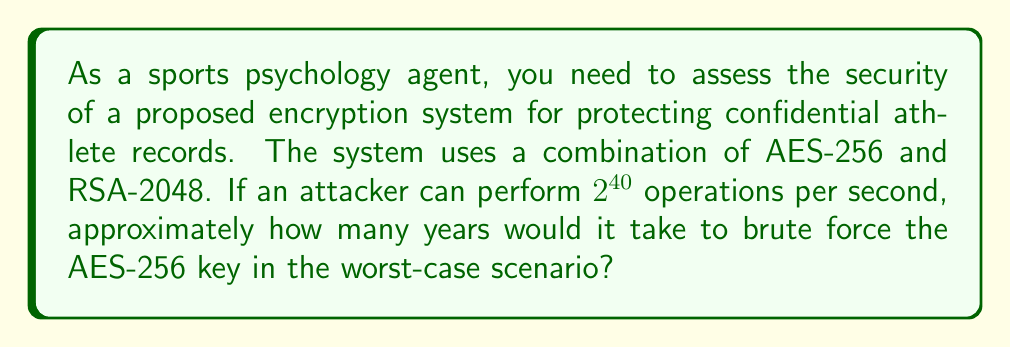Give your solution to this math problem. To solve this problem, we need to follow these steps:

1) First, let's consider the complexity of AES-256:
   - AES-256 has a key size of 256 bits
   - This means there are $2^{256}$ possible keys

2) Calculate the total number of operations needed:
   $$\text{Total operations} = 2^{256}$$

3) Convert the attacker's capability to operations per year:
   $$\text{Operations per year} = 2^{40} \times 60 \times 60 \times 24 \times 365.25$$
   $$= 2^{40} \times 31,557,600$$
   $$\approx 2^{65.54}$$

4) Calculate the time needed in years:
   $$\text{Years} = \frac{\text{Total operations}}{\text{Operations per year}}$$
   $$= \frac{2^{256}}{2^{65.54}}$$
   $$= 2^{256 - 65.54}$$
   $$= 2^{190.46}$$

5) Convert this to a decimal number:
   $$2^{190.46} \approx 1.6 \times 10^{57}$$

Therefore, it would take approximately $1.6 \times 10^{57}$ years to brute force the AES-256 key in the worst-case scenario.
Answer: $1.6 \times 10^{57}$ years 